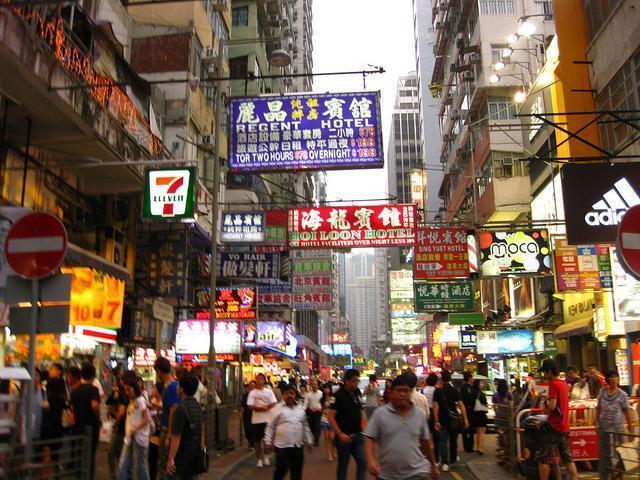How many people are there?
Give a very brief answer. 8. How many plates have a spoon on them?
Give a very brief answer. 0. 